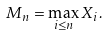<formula> <loc_0><loc_0><loc_500><loc_500>M _ { n } = \max _ { i \leq n } X _ { i } .</formula> 